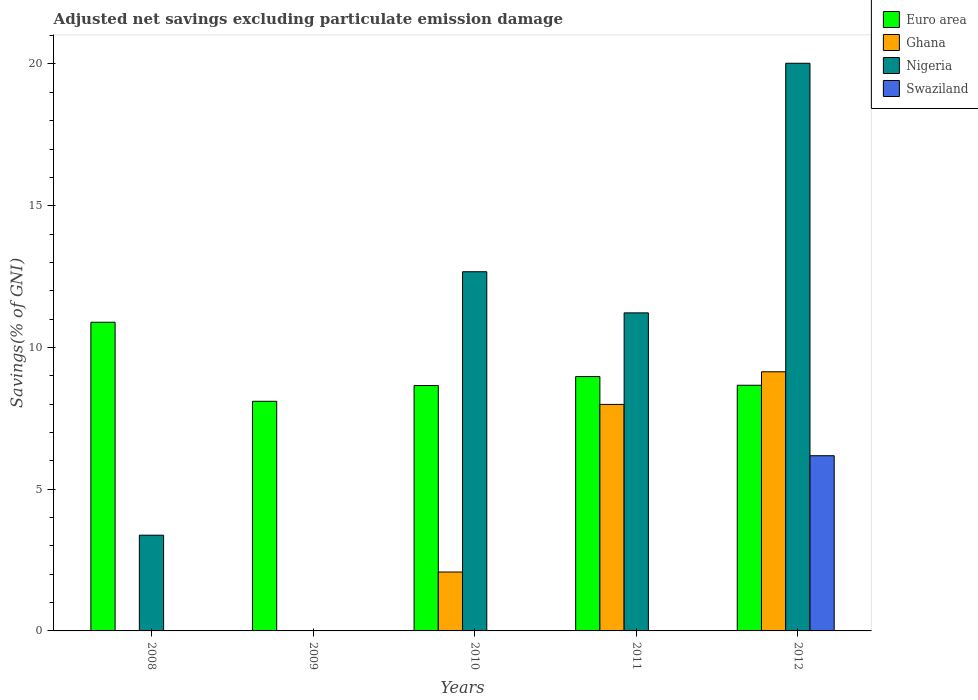How many different coloured bars are there?
Offer a terse response. 4. How many groups of bars are there?
Provide a succinct answer. 5. Are the number of bars per tick equal to the number of legend labels?
Your response must be concise. No. Are the number of bars on each tick of the X-axis equal?
Give a very brief answer. No. In how many cases, is the number of bars for a given year not equal to the number of legend labels?
Make the answer very short. 4. What is the adjusted net savings in Ghana in 2011?
Ensure brevity in your answer.  7.99. Across all years, what is the maximum adjusted net savings in Ghana?
Keep it short and to the point. 9.14. Across all years, what is the minimum adjusted net savings in Nigeria?
Offer a very short reply. 0. In which year was the adjusted net savings in Nigeria maximum?
Your answer should be very brief. 2012. What is the total adjusted net savings in Ghana in the graph?
Ensure brevity in your answer.  19.22. What is the difference between the adjusted net savings in Ghana in 2010 and that in 2011?
Ensure brevity in your answer.  -5.91. What is the difference between the adjusted net savings in Swaziland in 2010 and the adjusted net savings in Ghana in 2009?
Offer a terse response. -0.01. What is the average adjusted net savings in Ghana per year?
Ensure brevity in your answer.  3.84. In the year 2011, what is the difference between the adjusted net savings in Euro area and adjusted net savings in Ghana?
Provide a succinct answer. 0.98. What is the ratio of the adjusted net savings in Euro area in 2009 to that in 2012?
Keep it short and to the point. 0.93. Is the difference between the adjusted net savings in Euro area in 2011 and 2012 greater than the difference between the adjusted net savings in Ghana in 2011 and 2012?
Provide a succinct answer. Yes. What is the difference between the highest and the second highest adjusted net savings in Ghana?
Ensure brevity in your answer.  1.15. What is the difference between the highest and the lowest adjusted net savings in Euro area?
Offer a terse response. 2.79. How many bars are there?
Provide a short and direct response. 14. Are all the bars in the graph horizontal?
Your answer should be very brief. No. How many years are there in the graph?
Give a very brief answer. 5. Are the values on the major ticks of Y-axis written in scientific E-notation?
Your answer should be compact. No. Does the graph contain any zero values?
Keep it short and to the point. Yes. Does the graph contain grids?
Provide a short and direct response. No. Where does the legend appear in the graph?
Your answer should be compact. Top right. How many legend labels are there?
Offer a very short reply. 4. How are the legend labels stacked?
Your answer should be very brief. Vertical. What is the title of the graph?
Ensure brevity in your answer.  Adjusted net savings excluding particulate emission damage. Does "Arab World" appear as one of the legend labels in the graph?
Make the answer very short. No. What is the label or title of the X-axis?
Offer a terse response. Years. What is the label or title of the Y-axis?
Give a very brief answer. Savings(% of GNI). What is the Savings(% of GNI) in Euro area in 2008?
Keep it short and to the point. 10.89. What is the Savings(% of GNI) of Ghana in 2008?
Make the answer very short. 0. What is the Savings(% of GNI) in Nigeria in 2008?
Provide a short and direct response. 3.38. What is the Savings(% of GNI) in Euro area in 2009?
Your answer should be very brief. 8.1. What is the Savings(% of GNI) in Ghana in 2009?
Provide a succinct answer. 0.01. What is the Savings(% of GNI) of Euro area in 2010?
Offer a very short reply. 8.66. What is the Savings(% of GNI) in Ghana in 2010?
Make the answer very short. 2.08. What is the Savings(% of GNI) in Nigeria in 2010?
Your answer should be compact. 12.67. What is the Savings(% of GNI) of Euro area in 2011?
Ensure brevity in your answer.  8.97. What is the Savings(% of GNI) in Ghana in 2011?
Provide a short and direct response. 7.99. What is the Savings(% of GNI) of Nigeria in 2011?
Your answer should be very brief. 11.22. What is the Savings(% of GNI) in Swaziland in 2011?
Provide a succinct answer. 0. What is the Savings(% of GNI) of Euro area in 2012?
Provide a succinct answer. 8.67. What is the Savings(% of GNI) in Ghana in 2012?
Your response must be concise. 9.14. What is the Savings(% of GNI) in Nigeria in 2012?
Your answer should be very brief. 20.03. What is the Savings(% of GNI) of Swaziland in 2012?
Offer a very short reply. 6.18. Across all years, what is the maximum Savings(% of GNI) of Euro area?
Make the answer very short. 10.89. Across all years, what is the maximum Savings(% of GNI) of Ghana?
Make the answer very short. 9.14. Across all years, what is the maximum Savings(% of GNI) in Nigeria?
Provide a succinct answer. 20.03. Across all years, what is the maximum Savings(% of GNI) of Swaziland?
Provide a succinct answer. 6.18. Across all years, what is the minimum Savings(% of GNI) in Euro area?
Make the answer very short. 8.1. What is the total Savings(% of GNI) in Euro area in the graph?
Your answer should be compact. 45.29. What is the total Savings(% of GNI) in Ghana in the graph?
Keep it short and to the point. 19.22. What is the total Savings(% of GNI) in Nigeria in the graph?
Provide a short and direct response. 47.29. What is the total Savings(% of GNI) in Swaziland in the graph?
Your answer should be very brief. 6.18. What is the difference between the Savings(% of GNI) of Euro area in 2008 and that in 2009?
Keep it short and to the point. 2.79. What is the difference between the Savings(% of GNI) of Euro area in 2008 and that in 2010?
Make the answer very short. 2.23. What is the difference between the Savings(% of GNI) of Nigeria in 2008 and that in 2010?
Provide a succinct answer. -9.29. What is the difference between the Savings(% of GNI) of Euro area in 2008 and that in 2011?
Your answer should be compact. 1.92. What is the difference between the Savings(% of GNI) of Nigeria in 2008 and that in 2011?
Make the answer very short. -7.84. What is the difference between the Savings(% of GNI) of Euro area in 2008 and that in 2012?
Provide a succinct answer. 2.22. What is the difference between the Savings(% of GNI) of Nigeria in 2008 and that in 2012?
Your response must be concise. -16.65. What is the difference between the Savings(% of GNI) of Euro area in 2009 and that in 2010?
Ensure brevity in your answer.  -0.56. What is the difference between the Savings(% of GNI) of Ghana in 2009 and that in 2010?
Offer a very short reply. -2.07. What is the difference between the Savings(% of GNI) of Euro area in 2009 and that in 2011?
Your response must be concise. -0.87. What is the difference between the Savings(% of GNI) of Ghana in 2009 and that in 2011?
Provide a short and direct response. -7.98. What is the difference between the Savings(% of GNI) in Euro area in 2009 and that in 2012?
Your response must be concise. -0.57. What is the difference between the Savings(% of GNI) in Ghana in 2009 and that in 2012?
Offer a terse response. -9.13. What is the difference between the Savings(% of GNI) of Euro area in 2010 and that in 2011?
Provide a short and direct response. -0.32. What is the difference between the Savings(% of GNI) of Ghana in 2010 and that in 2011?
Your response must be concise. -5.91. What is the difference between the Savings(% of GNI) of Nigeria in 2010 and that in 2011?
Your answer should be compact. 1.45. What is the difference between the Savings(% of GNI) of Euro area in 2010 and that in 2012?
Provide a succinct answer. -0.01. What is the difference between the Savings(% of GNI) in Ghana in 2010 and that in 2012?
Give a very brief answer. -7.06. What is the difference between the Savings(% of GNI) in Nigeria in 2010 and that in 2012?
Your response must be concise. -7.35. What is the difference between the Savings(% of GNI) of Euro area in 2011 and that in 2012?
Your response must be concise. 0.31. What is the difference between the Savings(% of GNI) of Ghana in 2011 and that in 2012?
Ensure brevity in your answer.  -1.15. What is the difference between the Savings(% of GNI) of Nigeria in 2011 and that in 2012?
Offer a terse response. -8.81. What is the difference between the Savings(% of GNI) of Euro area in 2008 and the Savings(% of GNI) of Ghana in 2009?
Your answer should be very brief. 10.88. What is the difference between the Savings(% of GNI) in Euro area in 2008 and the Savings(% of GNI) in Ghana in 2010?
Ensure brevity in your answer.  8.81. What is the difference between the Savings(% of GNI) of Euro area in 2008 and the Savings(% of GNI) of Nigeria in 2010?
Give a very brief answer. -1.78. What is the difference between the Savings(% of GNI) of Euro area in 2008 and the Savings(% of GNI) of Ghana in 2011?
Your answer should be very brief. 2.9. What is the difference between the Savings(% of GNI) of Euro area in 2008 and the Savings(% of GNI) of Nigeria in 2011?
Provide a short and direct response. -0.33. What is the difference between the Savings(% of GNI) of Euro area in 2008 and the Savings(% of GNI) of Ghana in 2012?
Your answer should be compact. 1.75. What is the difference between the Savings(% of GNI) of Euro area in 2008 and the Savings(% of GNI) of Nigeria in 2012?
Keep it short and to the point. -9.14. What is the difference between the Savings(% of GNI) in Euro area in 2008 and the Savings(% of GNI) in Swaziland in 2012?
Your answer should be very brief. 4.71. What is the difference between the Savings(% of GNI) of Nigeria in 2008 and the Savings(% of GNI) of Swaziland in 2012?
Ensure brevity in your answer.  -2.8. What is the difference between the Savings(% of GNI) of Euro area in 2009 and the Savings(% of GNI) of Ghana in 2010?
Keep it short and to the point. 6.02. What is the difference between the Savings(% of GNI) in Euro area in 2009 and the Savings(% of GNI) in Nigeria in 2010?
Ensure brevity in your answer.  -4.57. What is the difference between the Savings(% of GNI) of Ghana in 2009 and the Savings(% of GNI) of Nigeria in 2010?
Provide a succinct answer. -12.66. What is the difference between the Savings(% of GNI) of Euro area in 2009 and the Savings(% of GNI) of Ghana in 2011?
Your answer should be very brief. 0.11. What is the difference between the Savings(% of GNI) of Euro area in 2009 and the Savings(% of GNI) of Nigeria in 2011?
Keep it short and to the point. -3.12. What is the difference between the Savings(% of GNI) in Ghana in 2009 and the Savings(% of GNI) in Nigeria in 2011?
Offer a very short reply. -11.21. What is the difference between the Savings(% of GNI) of Euro area in 2009 and the Savings(% of GNI) of Ghana in 2012?
Keep it short and to the point. -1.04. What is the difference between the Savings(% of GNI) in Euro area in 2009 and the Savings(% of GNI) in Nigeria in 2012?
Ensure brevity in your answer.  -11.92. What is the difference between the Savings(% of GNI) of Euro area in 2009 and the Savings(% of GNI) of Swaziland in 2012?
Your response must be concise. 1.92. What is the difference between the Savings(% of GNI) of Ghana in 2009 and the Savings(% of GNI) of Nigeria in 2012?
Offer a terse response. -20.02. What is the difference between the Savings(% of GNI) in Ghana in 2009 and the Savings(% of GNI) in Swaziland in 2012?
Provide a succinct answer. -6.17. What is the difference between the Savings(% of GNI) of Euro area in 2010 and the Savings(% of GNI) of Ghana in 2011?
Your response must be concise. 0.67. What is the difference between the Savings(% of GNI) of Euro area in 2010 and the Savings(% of GNI) of Nigeria in 2011?
Offer a very short reply. -2.56. What is the difference between the Savings(% of GNI) of Ghana in 2010 and the Savings(% of GNI) of Nigeria in 2011?
Offer a very short reply. -9.14. What is the difference between the Savings(% of GNI) in Euro area in 2010 and the Savings(% of GNI) in Ghana in 2012?
Provide a succinct answer. -0.48. What is the difference between the Savings(% of GNI) of Euro area in 2010 and the Savings(% of GNI) of Nigeria in 2012?
Ensure brevity in your answer.  -11.37. What is the difference between the Savings(% of GNI) in Euro area in 2010 and the Savings(% of GNI) in Swaziland in 2012?
Offer a terse response. 2.48. What is the difference between the Savings(% of GNI) of Ghana in 2010 and the Savings(% of GNI) of Nigeria in 2012?
Your response must be concise. -17.95. What is the difference between the Savings(% of GNI) of Ghana in 2010 and the Savings(% of GNI) of Swaziland in 2012?
Offer a very short reply. -4.1. What is the difference between the Savings(% of GNI) of Nigeria in 2010 and the Savings(% of GNI) of Swaziland in 2012?
Give a very brief answer. 6.49. What is the difference between the Savings(% of GNI) in Euro area in 2011 and the Savings(% of GNI) in Ghana in 2012?
Offer a terse response. -0.17. What is the difference between the Savings(% of GNI) in Euro area in 2011 and the Savings(% of GNI) in Nigeria in 2012?
Offer a very short reply. -11.05. What is the difference between the Savings(% of GNI) in Euro area in 2011 and the Savings(% of GNI) in Swaziland in 2012?
Your answer should be very brief. 2.79. What is the difference between the Savings(% of GNI) of Ghana in 2011 and the Savings(% of GNI) of Nigeria in 2012?
Your answer should be compact. -12.04. What is the difference between the Savings(% of GNI) in Ghana in 2011 and the Savings(% of GNI) in Swaziland in 2012?
Provide a short and direct response. 1.81. What is the difference between the Savings(% of GNI) of Nigeria in 2011 and the Savings(% of GNI) of Swaziland in 2012?
Provide a short and direct response. 5.04. What is the average Savings(% of GNI) of Euro area per year?
Offer a very short reply. 9.06. What is the average Savings(% of GNI) in Ghana per year?
Provide a succinct answer. 3.84. What is the average Savings(% of GNI) of Nigeria per year?
Give a very brief answer. 9.46. What is the average Savings(% of GNI) of Swaziland per year?
Offer a terse response. 1.24. In the year 2008, what is the difference between the Savings(% of GNI) in Euro area and Savings(% of GNI) in Nigeria?
Offer a very short reply. 7.51. In the year 2009, what is the difference between the Savings(% of GNI) in Euro area and Savings(% of GNI) in Ghana?
Give a very brief answer. 8.09. In the year 2010, what is the difference between the Savings(% of GNI) in Euro area and Savings(% of GNI) in Ghana?
Provide a short and direct response. 6.58. In the year 2010, what is the difference between the Savings(% of GNI) in Euro area and Savings(% of GNI) in Nigeria?
Offer a terse response. -4.01. In the year 2010, what is the difference between the Savings(% of GNI) of Ghana and Savings(% of GNI) of Nigeria?
Provide a succinct answer. -10.59. In the year 2011, what is the difference between the Savings(% of GNI) in Euro area and Savings(% of GNI) in Ghana?
Your response must be concise. 0.98. In the year 2011, what is the difference between the Savings(% of GNI) in Euro area and Savings(% of GNI) in Nigeria?
Your response must be concise. -2.25. In the year 2011, what is the difference between the Savings(% of GNI) in Ghana and Savings(% of GNI) in Nigeria?
Ensure brevity in your answer.  -3.23. In the year 2012, what is the difference between the Savings(% of GNI) of Euro area and Savings(% of GNI) of Ghana?
Ensure brevity in your answer.  -0.47. In the year 2012, what is the difference between the Savings(% of GNI) in Euro area and Savings(% of GNI) in Nigeria?
Ensure brevity in your answer.  -11.36. In the year 2012, what is the difference between the Savings(% of GNI) of Euro area and Savings(% of GNI) of Swaziland?
Ensure brevity in your answer.  2.49. In the year 2012, what is the difference between the Savings(% of GNI) in Ghana and Savings(% of GNI) in Nigeria?
Ensure brevity in your answer.  -10.88. In the year 2012, what is the difference between the Savings(% of GNI) of Ghana and Savings(% of GNI) of Swaziland?
Provide a short and direct response. 2.96. In the year 2012, what is the difference between the Savings(% of GNI) in Nigeria and Savings(% of GNI) in Swaziland?
Keep it short and to the point. 13.85. What is the ratio of the Savings(% of GNI) of Euro area in 2008 to that in 2009?
Your answer should be very brief. 1.34. What is the ratio of the Savings(% of GNI) in Euro area in 2008 to that in 2010?
Ensure brevity in your answer.  1.26. What is the ratio of the Savings(% of GNI) in Nigeria in 2008 to that in 2010?
Offer a terse response. 0.27. What is the ratio of the Savings(% of GNI) of Euro area in 2008 to that in 2011?
Offer a terse response. 1.21. What is the ratio of the Savings(% of GNI) of Nigeria in 2008 to that in 2011?
Your answer should be very brief. 0.3. What is the ratio of the Savings(% of GNI) in Euro area in 2008 to that in 2012?
Keep it short and to the point. 1.26. What is the ratio of the Savings(% of GNI) of Nigeria in 2008 to that in 2012?
Keep it short and to the point. 0.17. What is the ratio of the Savings(% of GNI) of Euro area in 2009 to that in 2010?
Offer a terse response. 0.94. What is the ratio of the Savings(% of GNI) in Ghana in 2009 to that in 2010?
Provide a succinct answer. 0. What is the ratio of the Savings(% of GNI) in Euro area in 2009 to that in 2011?
Make the answer very short. 0.9. What is the ratio of the Savings(% of GNI) in Ghana in 2009 to that in 2011?
Keep it short and to the point. 0. What is the ratio of the Savings(% of GNI) in Euro area in 2009 to that in 2012?
Make the answer very short. 0.93. What is the ratio of the Savings(% of GNI) in Ghana in 2009 to that in 2012?
Offer a terse response. 0. What is the ratio of the Savings(% of GNI) in Euro area in 2010 to that in 2011?
Your answer should be compact. 0.96. What is the ratio of the Savings(% of GNI) in Ghana in 2010 to that in 2011?
Provide a short and direct response. 0.26. What is the ratio of the Savings(% of GNI) in Nigeria in 2010 to that in 2011?
Provide a short and direct response. 1.13. What is the ratio of the Savings(% of GNI) of Euro area in 2010 to that in 2012?
Your answer should be very brief. 1. What is the ratio of the Savings(% of GNI) of Ghana in 2010 to that in 2012?
Your answer should be very brief. 0.23. What is the ratio of the Savings(% of GNI) of Nigeria in 2010 to that in 2012?
Your answer should be compact. 0.63. What is the ratio of the Savings(% of GNI) of Euro area in 2011 to that in 2012?
Your response must be concise. 1.04. What is the ratio of the Savings(% of GNI) in Ghana in 2011 to that in 2012?
Make the answer very short. 0.87. What is the ratio of the Savings(% of GNI) in Nigeria in 2011 to that in 2012?
Give a very brief answer. 0.56. What is the difference between the highest and the second highest Savings(% of GNI) in Euro area?
Provide a short and direct response. 1.92. What is the difference between the highest and the second highest Savings(% of GNI) of Ghana?
Your response must be concise. 1.15. What is the difference between the highest and the second highest Savings(% of GNI) in Nigeria?
Make the answer very short. 7.35. What is the difference between the highest and the lowest Savings(% of GNI) in Euro area?
Your answer should be compact. 2.79. What is the difference between the highest and the lowest Savings(% of GNI) of Ghana?
Offer a very short reply. 9.14. What is the difference between the highest and the lowest Savings(% of GNI) in Nigeria?
Provide a succinct answer. 20.03. What is the difference between the highest and the lowest Savings(% of GNI) in Swaziland?
Your answer should be very brief. 6.18. 